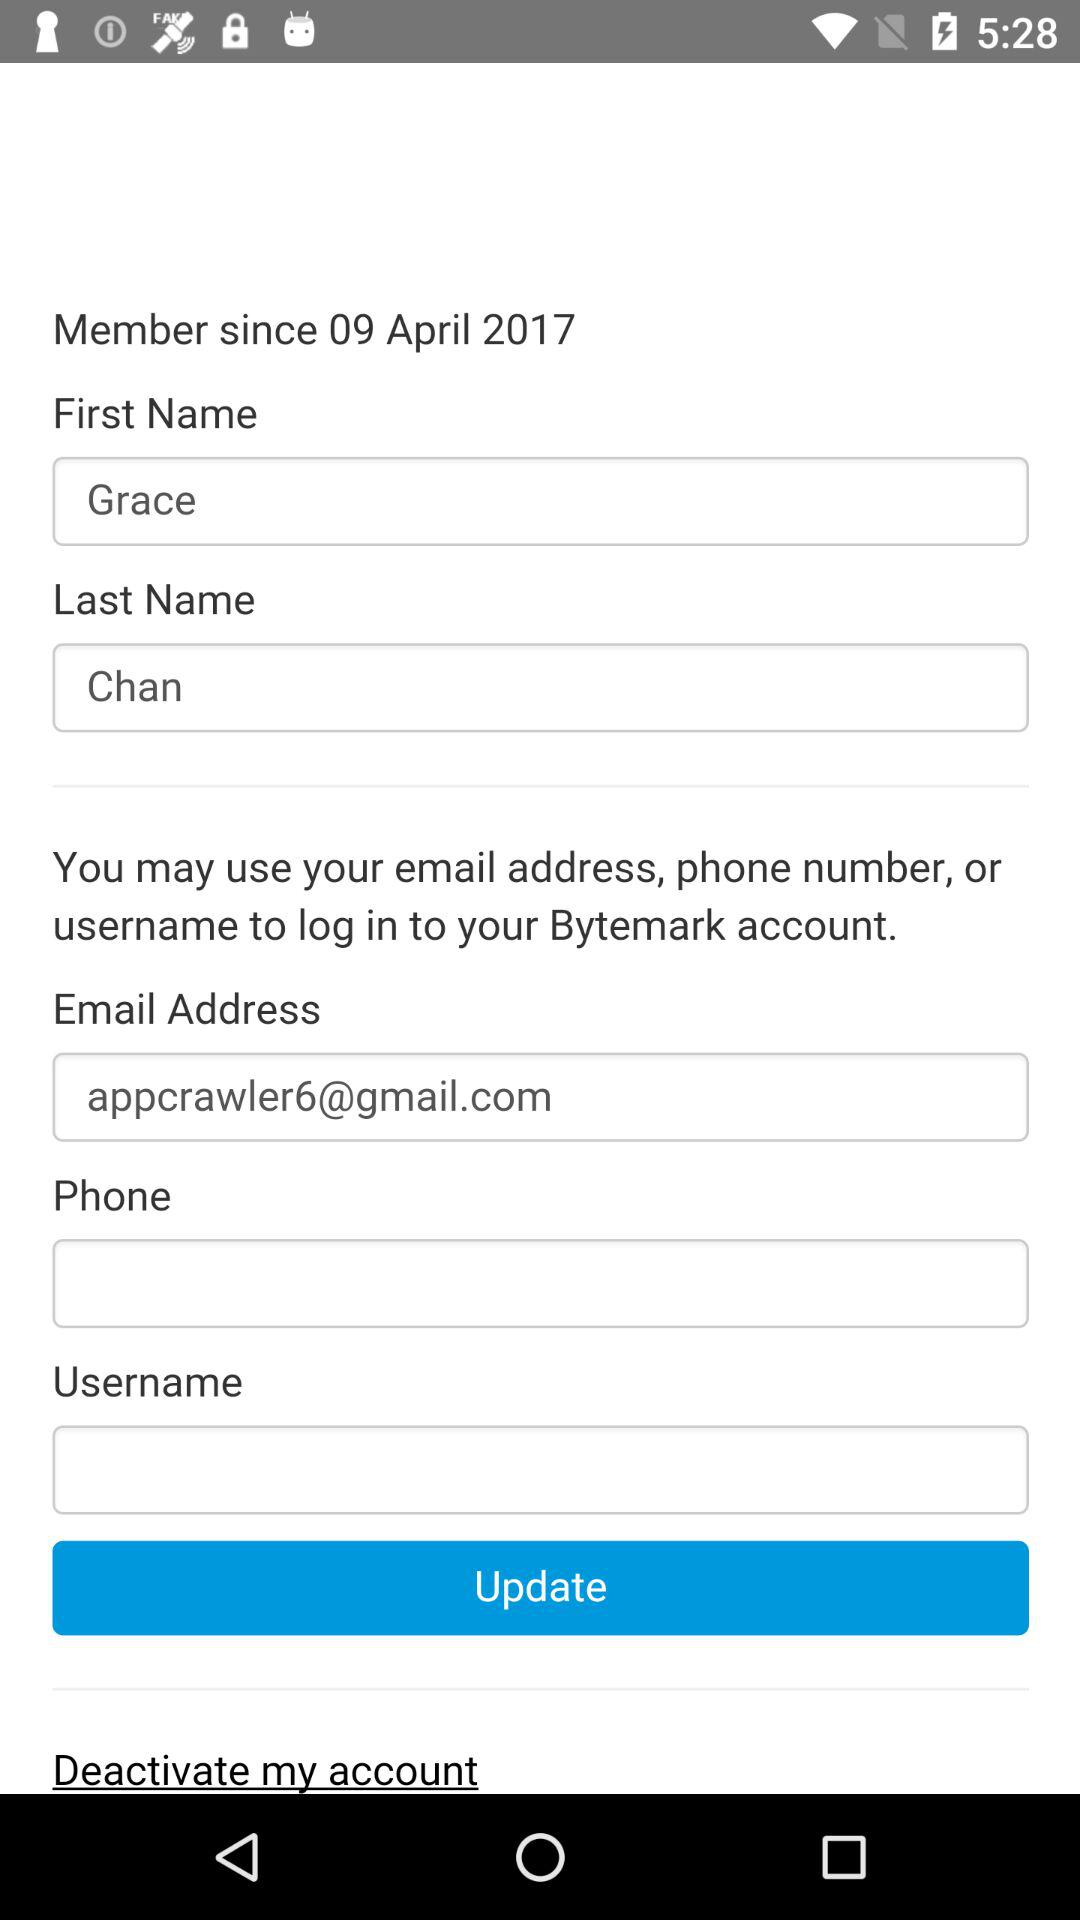How many text inputs are there that are not empty?
Answer the question using a single word or phrase. 3 